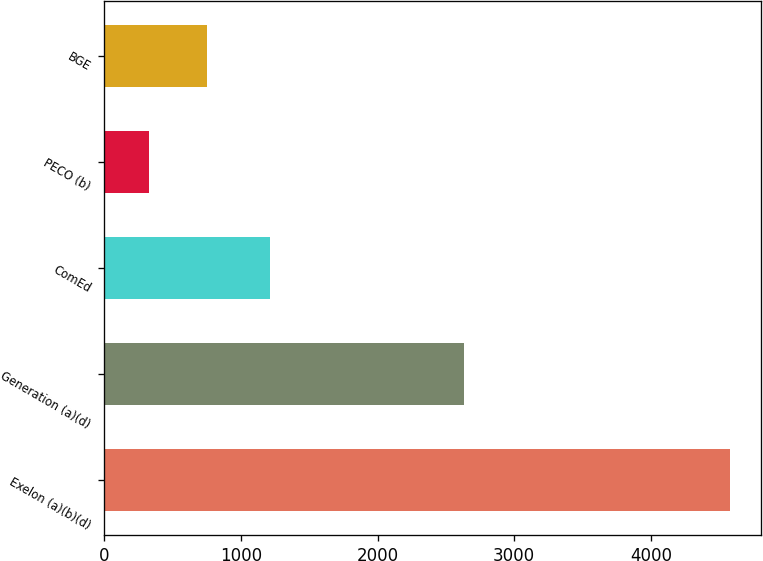<chart> <loc_0><loc_0><loc_500><loc_500><bar_chart><fcel>Exelon (a)(b)(d)<fcel>Generation (a)(d)<fcel>ComEd<fcel>PECO (b)<fcel>BGE<nl><fcel>4576<fcel>2629<fcel>1212<fcel>328<fcel>752.8<nl></chart> 